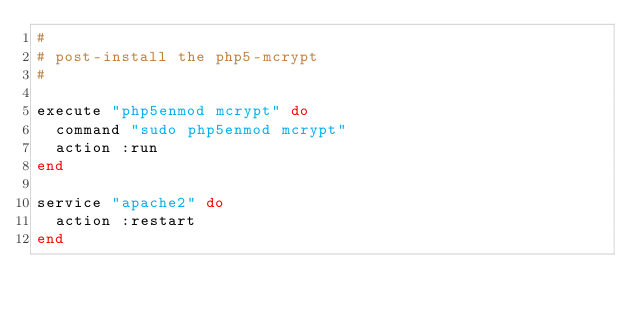Convert code to text. <code><loc_0><loc_0><loc_500><loc_500><_Ruby_>#
# post-install the php5-mcrypt
#

execute "php5enmod mcrypt" do
  command "sudo php5enmod mcrypt" 
  action :run
end

service "apache2" do
  action :restart
end
</code> 